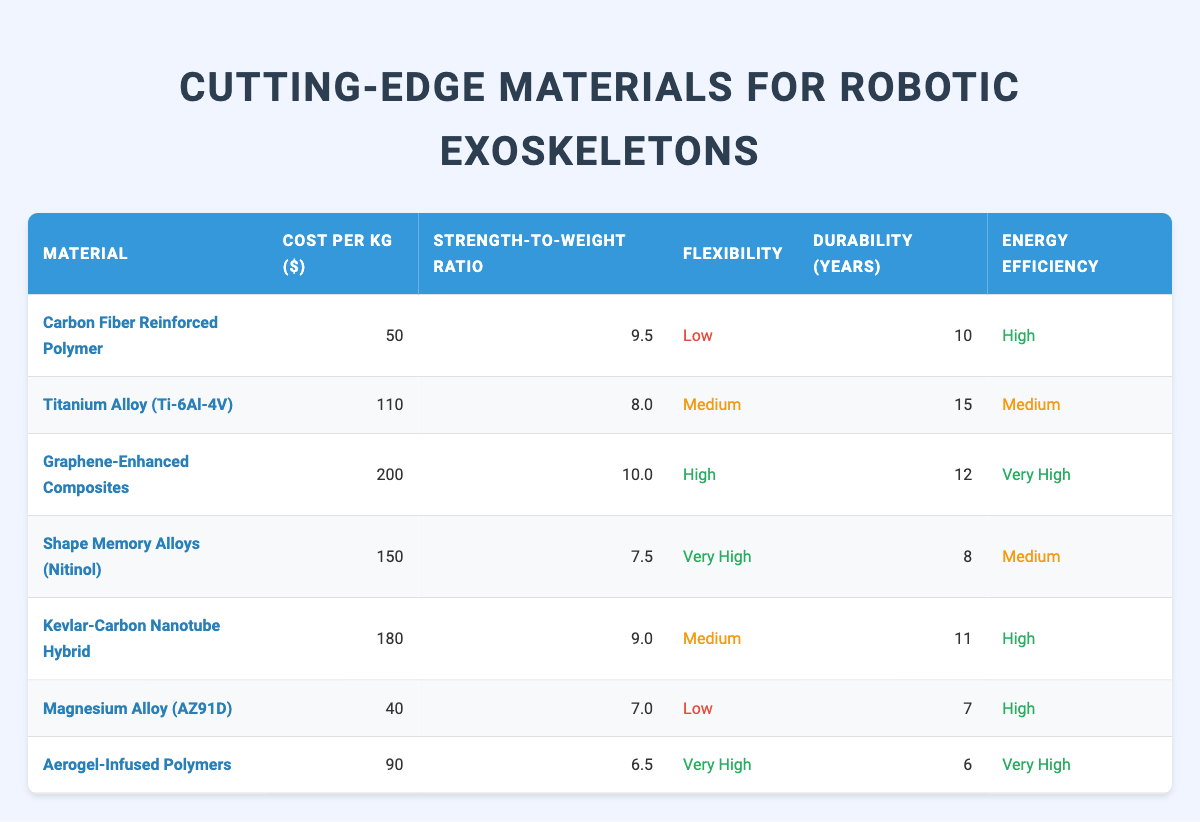What is the cost per kg of Graphene-Enhanced Composites? The table lists Graphene-Enhanced Composites under the "Material" column, with the corresponding value in the "Cost per kg ($)" column as 200.
Answer: 200 Which material has the highest Strength-to-Weight Ratio? Scanning through the "Strength-to-Weight Ratio" column, Graphene-Enhanced Composites has the highest ratio of 10.0 compared to other materials listed.
Answer: Graphene-Enhanced Composites Is the Flexibility of Titanium Alloy (Ti-6Al-4V) considered high? The table shows that the flexibility level for Titanium Alloy (Ti-6Al-4V) is labeled as "Medium," which means it is not classified as high.
Answer: No What is the average Durability (in years) of the materials listed? To find the average, sum up the durability values (10 + 15 + 12 + 8 + 11 + 7 + 6 = 69) and divide by the number of materials (7). Thus, the average durability is 69/7 = 9.857, rounded to two decimal places gives 9.86.
Answer: 9.86 Which material is the least expensive per kg? By reviewing the "Cost per kg ($)" column, Magnesium Alloy (AZ91D) shows the lowest cost at 40, making it the least expensive material in the table.
Answer: Magnesium Alloy (AZ91D) Is the Energy Efficiency of Aerogel-Infused Polymers categorized as low? In the "Energy Efficiency" column, Aerogel-Infused Polymers is categorized as "Very High," which indicates it is not categorized as low.
Answer: No How does the cost of Shape Memory Alloys (Nitinol) compare to Carbon Fiber Reinforced Polymer? The cost for Shape Memory Alloys (Nitinol) is 150, while for Carbon Fiber Reinforced Polymer it is 50. 150 is higher than 50. Therefore, Shape Memory Alloys (Nitinol) is more expensive.
Answer: More expensive Which material has both high Strength-to-Weight Ratio and high Energy Efficiency? By examining the table, Graphene-Enhanced Composites has a Strength-to-Weight Ratio of 10.0 and Energy Efficiency classified as "Very High," meeting both criteria.
Answer: Graphene-Enhanced Composites What is the difference in cost between the most expensive and the least expensive material? The most expensive material is Graphene-Enhanced Composites at 200, while the least expensive is Magnesium Alloy (AZ91D) at 40. The difference is calculated as 200 - 40 = 160.
Answer: 160 